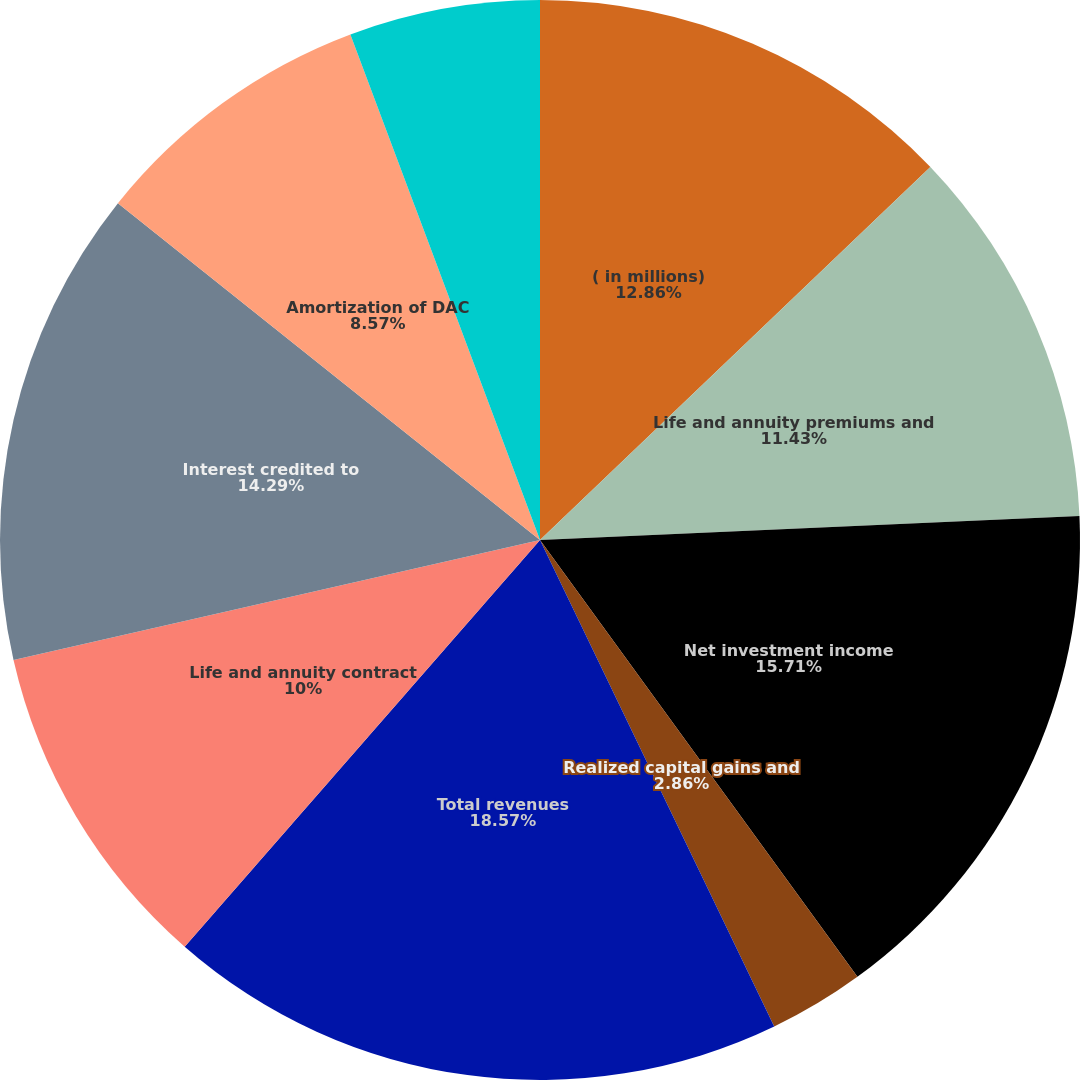<chart> <loc_0><loc_0><loc_500><loc_500><pie_chart><fcel>( in millions)<fcel>Life and annuity premiums and<fcel>Net investment income<fcel>Realized capital gains and<fcel>Total revenues<fcel>Life and annuity contract<fcel>Interest credited to<fcel>Amortization of DAC<fcel>Operating costs and expenses<fcel>Restructuring and related<nl><fcel>12.86%<fcel>11.43%<fcel>15.71%<fcel>2.86%<fcel>18.57%<fcel>10.0%<fcel>14.29%<fcel>8.57%<fcel>5.71%<fcel>0.0%<nl></chart> 